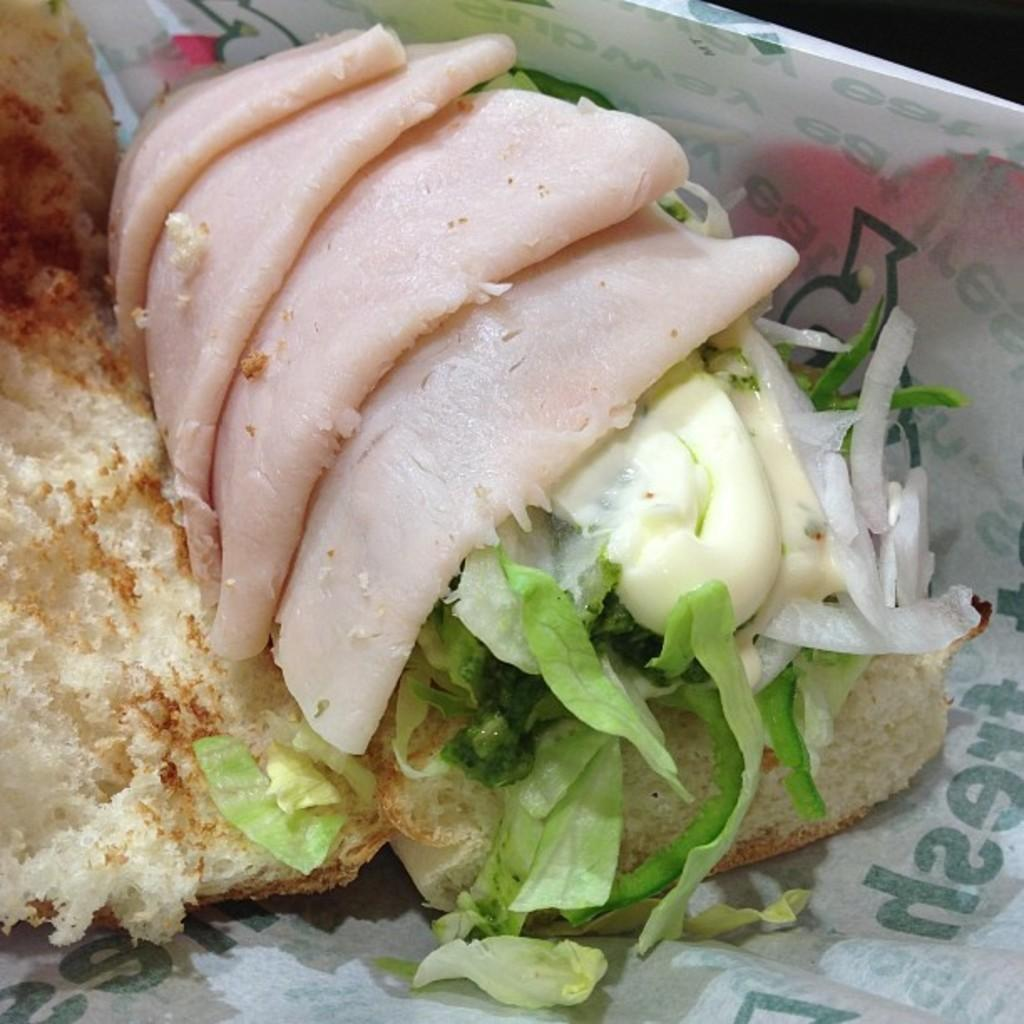What type of food items can be seen in the image? There are eatables in the image, including bread, lettuce, mayonnaise, and meat. Can you describe the bread in the image? Yes, there is bread in the image. What type of vegetable is present in the image? There is lettuce in the image. What condiment can be seen in the image? There is mayonnaise in the image. What type of meat is visible in the image? There is meat in the image. What type of marble is used as a tabletop in the image? There is no marble tabletop present in the image. What type of jeans is the person wearing in the image? There is no person or jeans visible in the image. 